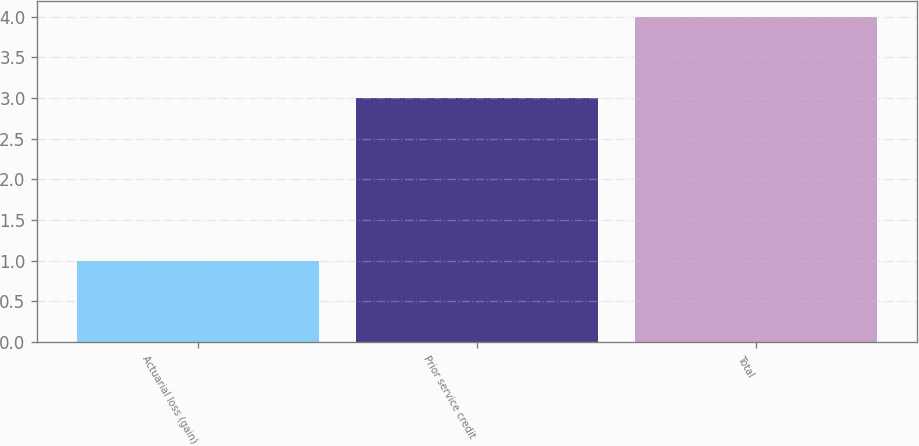Convert chart. <chart><loc_0><loc_0><loc_500><loc_500><bar_chart><fcel>Actuarial loss (gain)<fcel>Prior service credit<fcel>Total<nl><fcel>1<fcel>3<fcel>4<nl></chart> 